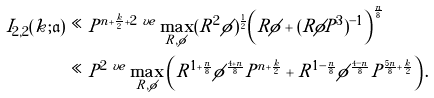Convert formula to latex. <formula><loc_0><loc_0><loc_500><loc_500>I _ { 2 , 2 } ( k ; \mathfrak { a } ) & \ll P ^ { n + \frac { k } { 2 } + 2 \ v e } \max _ { R , \phi } ( R ^ { 2 } \phi ) ^ { \frac { 1 } { 2 } } \left ( R \phi + ( R \phi P ^ { 3 } ) ^ { - 1 } \right ) ^ { \frac { n } { 8 } } \\ & \ll P ^ { 2 \ v e } \max _ { R , \phi } \left ( R ^ { 1 + \frac { n } { 8 } } \phi ^ { \frac { 4 + n } { 8 } } P ^ { n + \frac { k } { 2 } } + R ^ { 1 - \frac { n } { 8 } } \phi ^ { \frac { 4 - n } { 8 } } P ^ { \frac { 5 n } { 8 } + \frac { k } { 2 } } \right ) .</formula> 